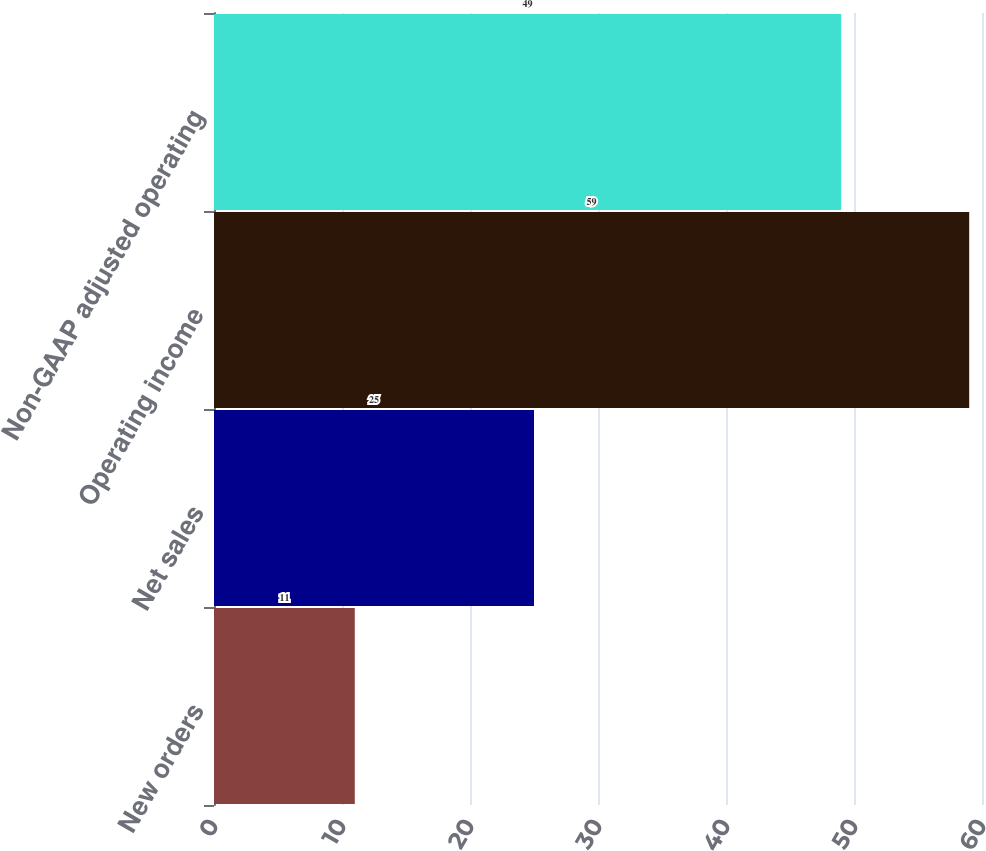<chart> <loc_0><loc_0><loc_500><loc_500><bar_chart><fcel>New orders<fcel>Net sales<fcel>Operating income<fcel>Non-GAAP adjusted operating<nl><fcel>11<fcel>25<fcel>59<fcel>49<nl></chart> 